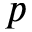Convert formula to latex. <formula><loc_0><loc_0><loc_500><loc_500>p</formula> 